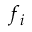<formula> <loc_0><loc_0><loc_500><loc_500>f _ { i }</formula> 